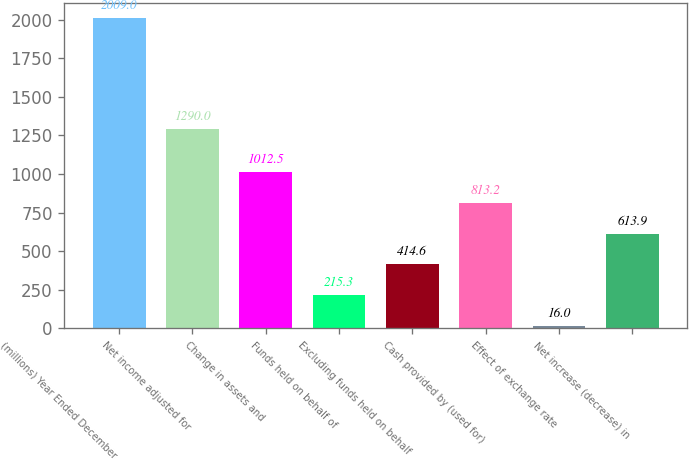Convert chart to OTSL. <chart><loc_0><loc_0><loc_500><loc_500><bar_chart><fcel>(millions) Year Ended December<fcel>Net income adjusted for<fcel>Change in assets and<fcel>Funds held on behalf of<fcel>Excluding funds held on behalf<fcel>Cash provided by (used for)<fcel>Effect of exchange rate<fcel>Net increase (decrease) in<nl><fcel>2009<fcel>1290<fcel>1012.5<fcel>215.3<fcel>414.6<fcel>813.2<fcel>16<fcel>613.9<nl></chart> 